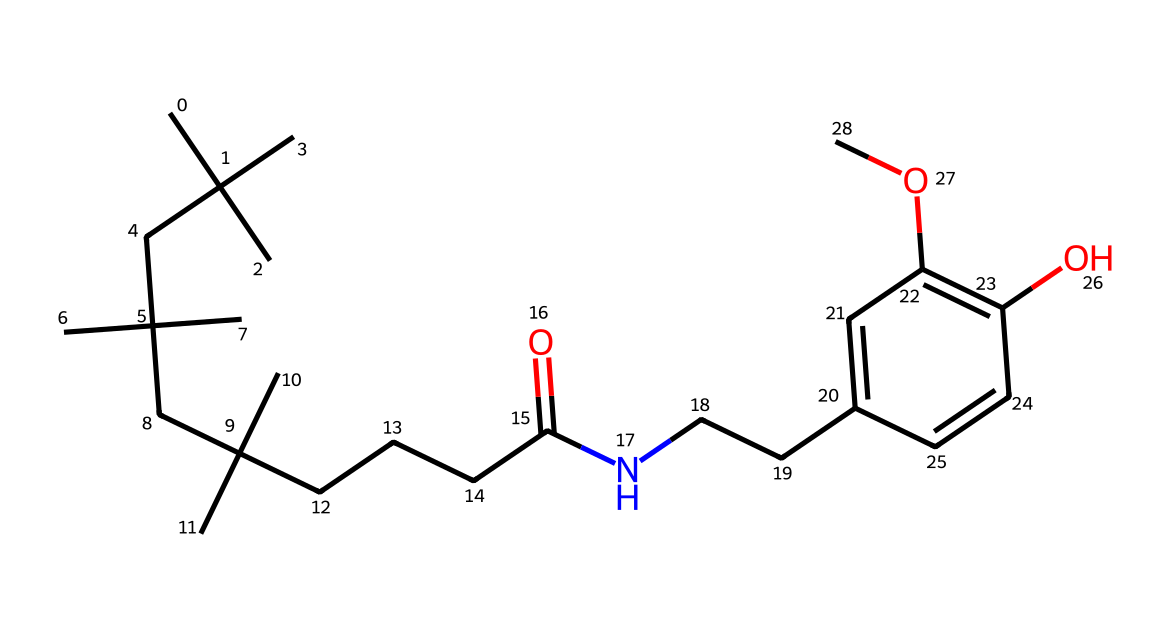What is the primary functional group in capsaicin? The primary functional group in capsaicin is the amide group, which is indicated by the presence of the nitrogen atom connected to a carbonyl (C=O) and a hydrocarbon chain.
Answer: amide How many carbon atoms are present in capsaicin? By examining the SMILES representation, one can count a total of 17 carbon atoms (C) listed throughout the structure of capsaicin.
Answer: 17 Does capsaicin contain any double bonds? Yes, upon reviewing the chemical structure, it can be seen that there are double bonds present (notably in the aromatic ring and in the carbonyl group).
Answer: yes Which part of the structure is responsible for capsaicin's spiciness? The spiciness is mainly attributed to the vanillyl group (aromatic ring with the methoxy and hydroxyl groups), situated within the overall structure of capsaicin.
Answer: vanillyl group What kind of bond connects the nitrogen atom in the amide group to the carbon chain? The bond connecting the nitrogen atom in the amide group to the carbon chain is a single covalent bond, indicated by the simple connection without additional symbols for double or triple bonds.
Answer: single covalent bond How many oxygen atoms are present in capsaicin? Counting within the structure shows that capsaicin contains three oxygen atoms (O) indicating functional groups such as the carbonyl and hydroxyl.
Answer: 3 Are there any cyclic structures in capsaicin? Yes, the presence of the aromatic ring, which is a type of cyclic structure, can be clearly identified in the chemical's structure.
Answer: yes 